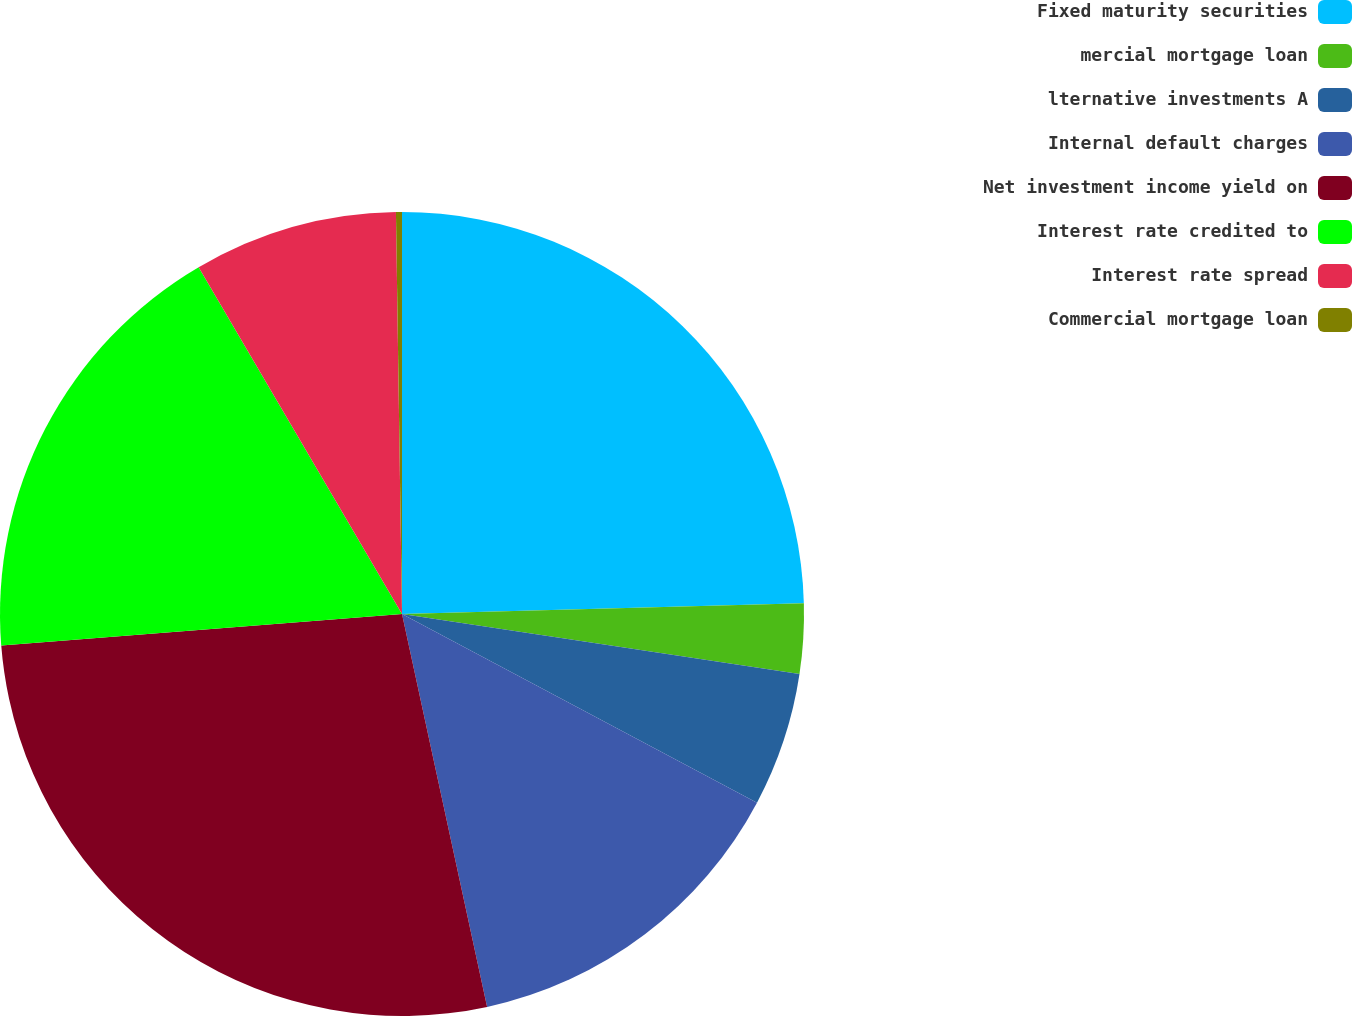<chart> <loc_0><loc_0><loc_500><loc_500><pie_chart><fcel>Fixed maturity securities<fcel>mercial mortgage loan<fcel>lternative investments A<fcel>Internal default charges<fcel>Net investment income yield on<fcel>Interest rate credited to<fcel>Interest rate spread<fcel>Commercial mortgage loan<nl><fcel>24.57%<fcel>2.81%<fcel>5.39%<fcel>13.83%<fcel>27.14%<fcel>17.81%<fcel>8.2%<fcel>0.24%<nl></chart> 